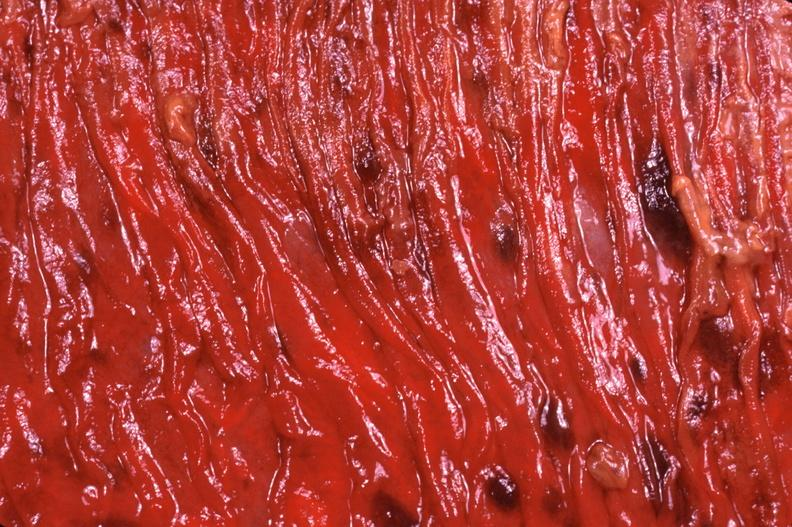does immunostain for growth hormone show duodenum, necrotizing enteritis with pseudomembrane, candida?
Answer the question using a single word or phrase. No 